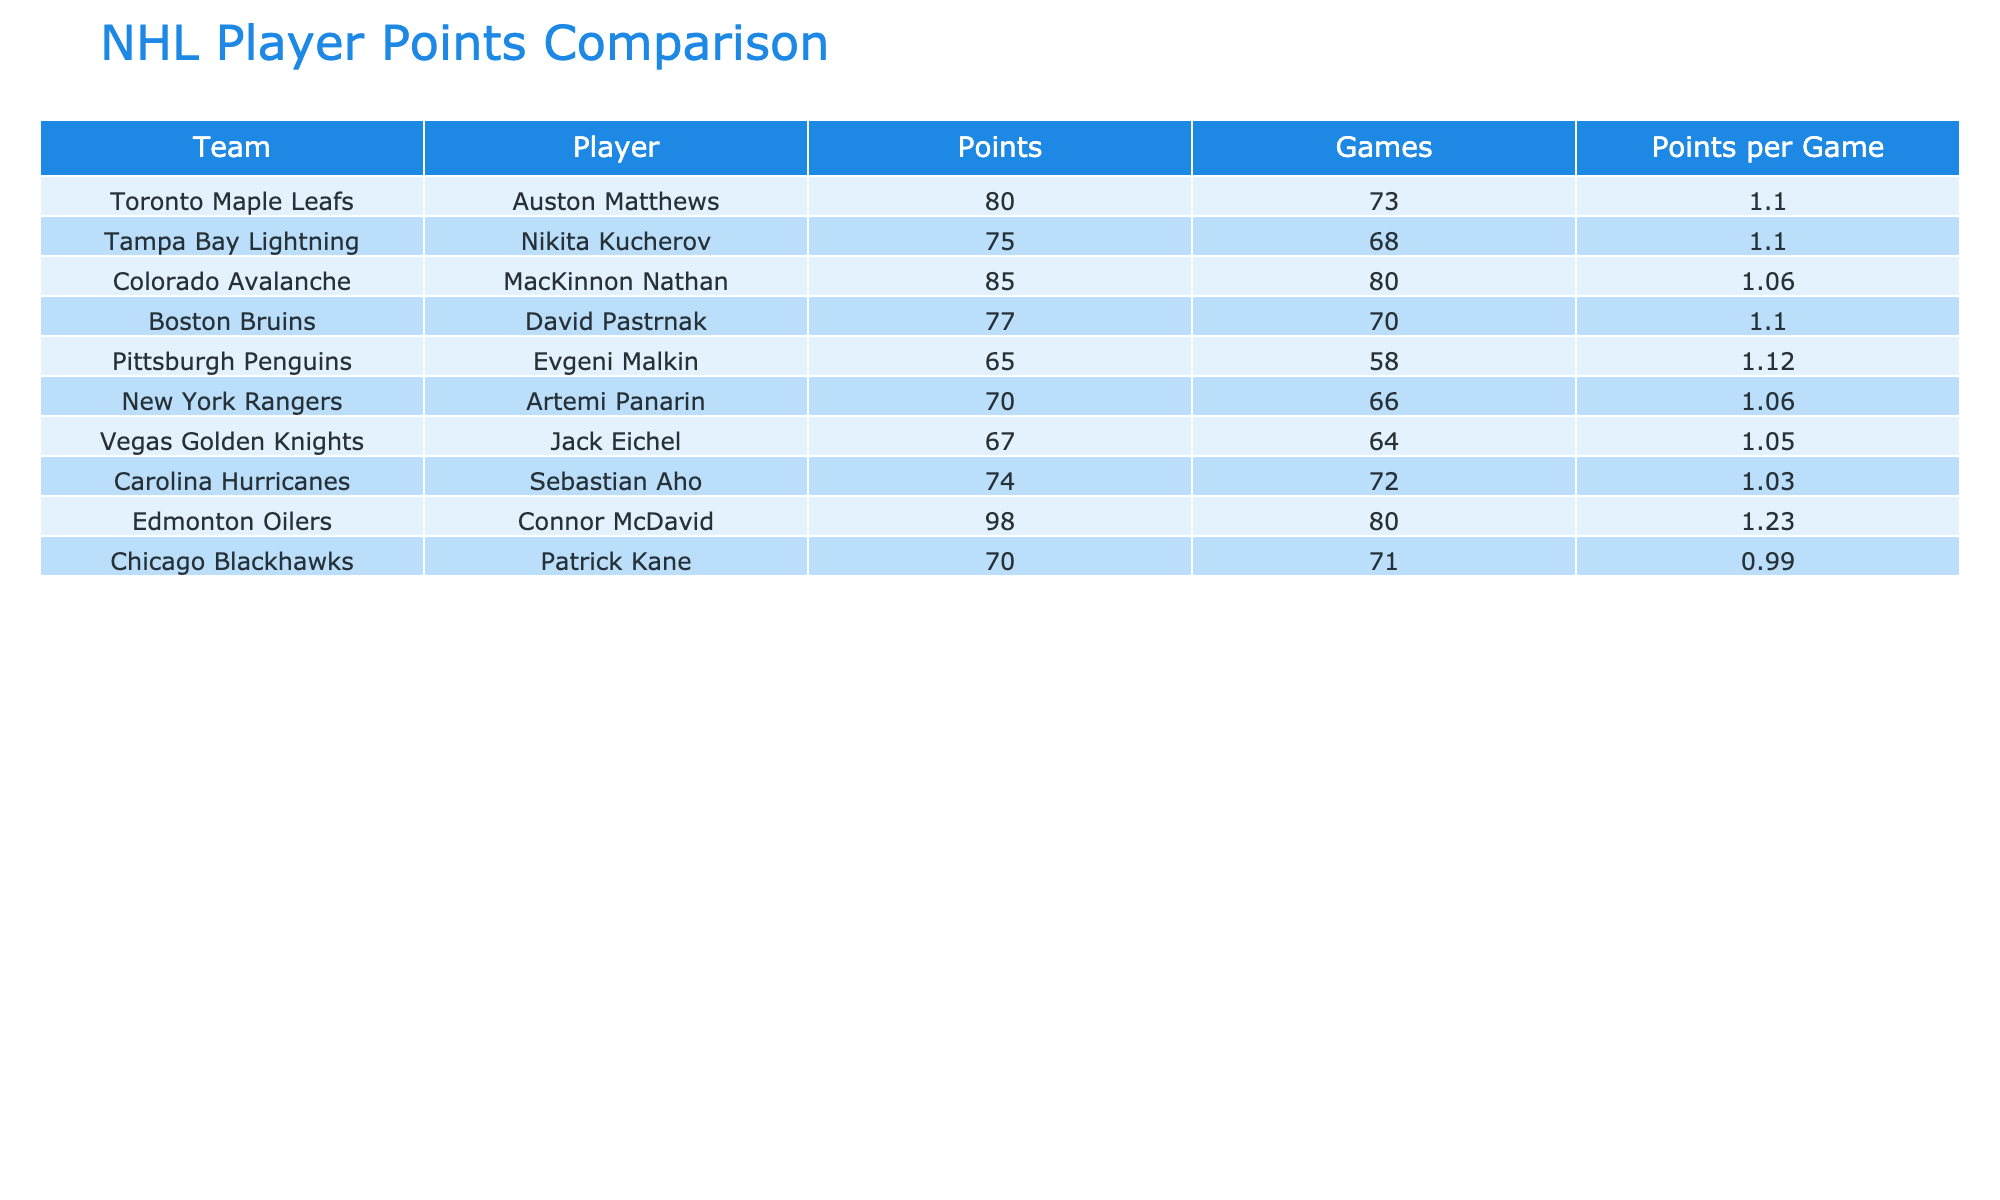What is the highest points per game among the players listed? By reviewing the "Points per Game" column, I can easily identify the value that stands out as the highest. The values in that column are 1.10, 1.10, 1.06, 1.10, 1.12, 1.06, 1.05, 1.03, 1.23, and 0.99. The highest value here is 1.23, corresponding to Connor McDavid.
Answer: 1.23 Which team does Evgeni Malkin play for, and what is his points per game? By locating Evgeni Malkin in the table, I find that he is part of the Pittsburgh Penguins. Now, I check the "Points per Game" column next to his name and see that it is 1.12.
Answer: Pittsburgh Penguins, 1.12 What is the average points per game for players on the Boston Bruins and the New York Rangers? First, I identify the "Points per Game" for David Pastrnak of the Boston Bruins, which is 1.10, and Artemi Panarin of the New York Rangers, which is 1.06. To calculate the average, I add these two values: 1.10 + 1.06 = 2.16. Then, I divide by the number of players (2): 2.16 / 2 = 1.08.
Answer: 1.08 Is Nikita Kucherov's points per game higher than Jack Eichel's? I compare the values in the "Points per Game" column for both players. Nikita Kucherov has 1.10, while Jack Eichel has 1.05. Since 1.10 is greater than 1.05, the answer is yes.
Answer: Yes Which player has the most points, and how does their points per game compare to that of Patrick Kane? Reviewing the "Points" column, I see that Connor McDavid has the most points at 98. To compare with Patrick Kane, who has 70 points, I check their "Points per Game": Connor McDavid is 1.23, while Patrick Kane is 0.99. Therefore, Connor McDavid’s points per game is higher.
Answer: Connor McDavid, higher than Patrick Kane How many players have a points per game of 1.10 or more? I scan the "Points per Game" column and count the players with values of 1.10 or above: Auston Matthews (1.10), Nikita Kucherov (1.10), David Pastrnak (1.10), Evgeni Malkin (1.12), and Connor McDavid (1.23) appear to meet that criteria. This totals five players.
Answer: 5 What is the difference in points per game between the players from the Toronto Maple Leafs and Edmonton Oilers? I identify the points per game for the Toronto Maple Leafs player (Auston Matthews: 1.10) and for the Edmonton Oilers player (Connor McDavid: 1.23). I then calculate the difference: 1.23 - 1.10 = 0.13, indicating that Connor McDavid has a higher points per game by this amount.
Answer: 0.13 Has any player from the Carolina Hurricanes scored over 75 points? Looking at the "Points" column for Sebastian Aho, I find that he has scored 74 points, which is lower than 75. Hence, no player from the Carolina Hurricanes has scored over 75 points.
Answer: No 